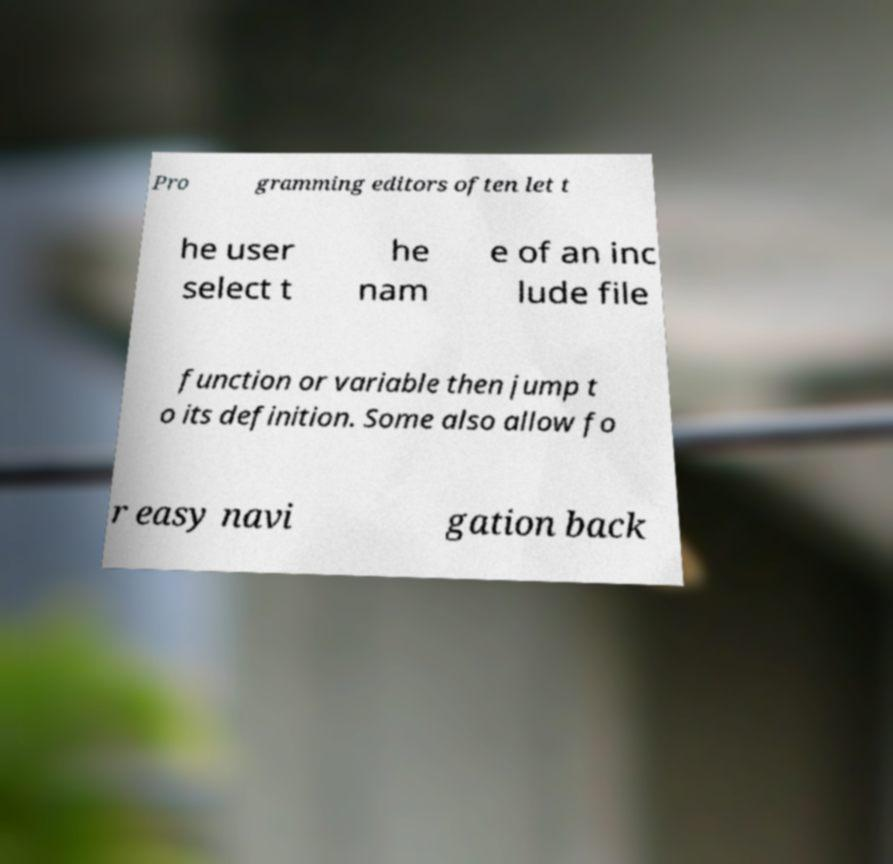For documentation purposes, I need the text within this image transcribed. Could you provide that? Pro gramming editors often let t he user select t he nam e of an inc lude file function or variable then jump t o its definition. Some also allow fo r easy navi gation back 